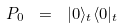<formula> <loc_0><loc_0><loc_500><loc_500>P _ { 0 } \ = \ | 0 \rangle _ { t } \langle 0 | _ { t }</formula> 